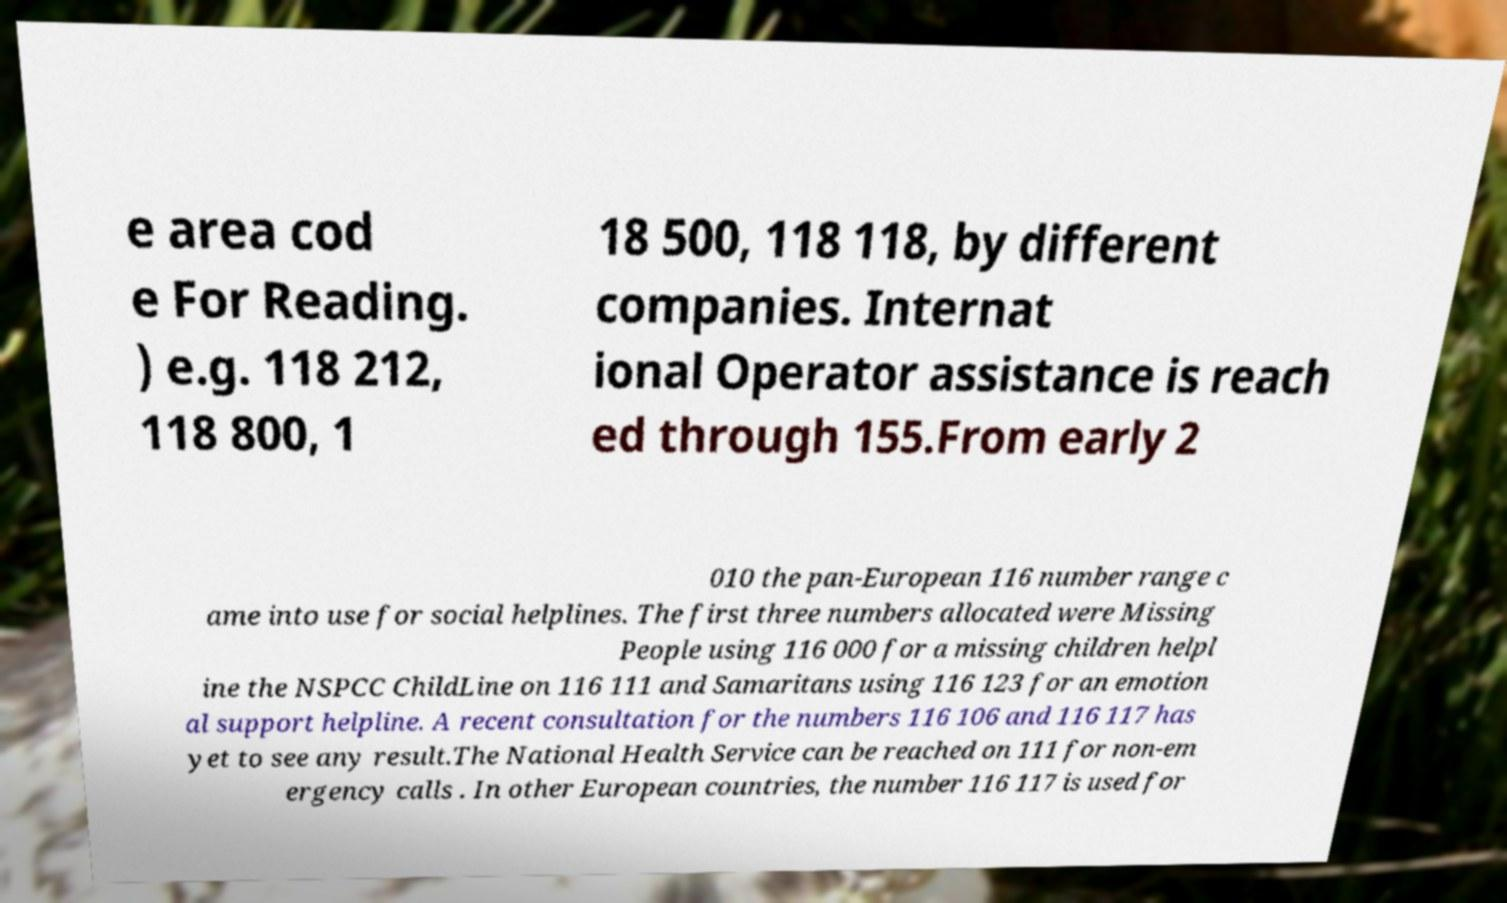For documentation purposes, I need the text within this image transcribed. Could you provide that? e area cod e For Reading. ) e.g. 118 212, 118 800, 1 18 500, 118 118, by different companies. Internat ional Operator assistance is reach ed through 155.From early 2 010 the pan-European 116 number range c ame into use for social helplines. The first three numbers allocated were Missing People using 116 000 for a missing children helpl ine the NSPCC ChildLine on 116 111 and Samaritans using 116 123 for an emotion al support helpline. A recent consultation for the numbers 116 106 and 116 117 has yet to see any result.The National Health Service can be reached on 111 for non-em ergency calls . In other European countries, the number 116 117 is used for 